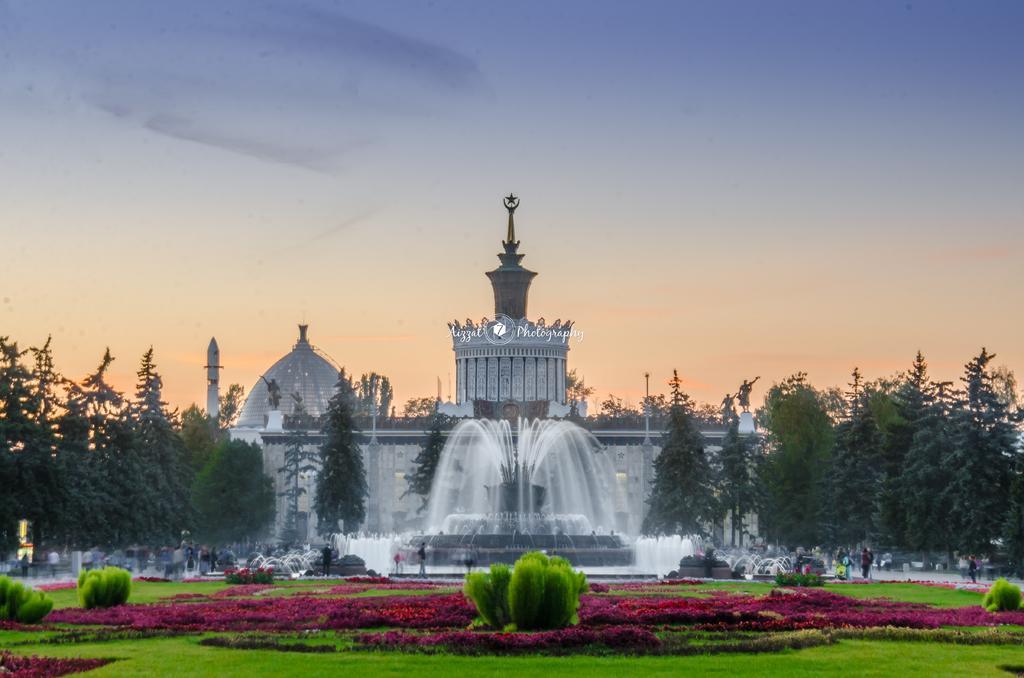In one or two sentences, can you explain what this image depicts? In the image we can see the ground is covered with grass and in between there are plants. Behind there is a water fountain and there is building. There are lot of trees on both the sides of the building. 